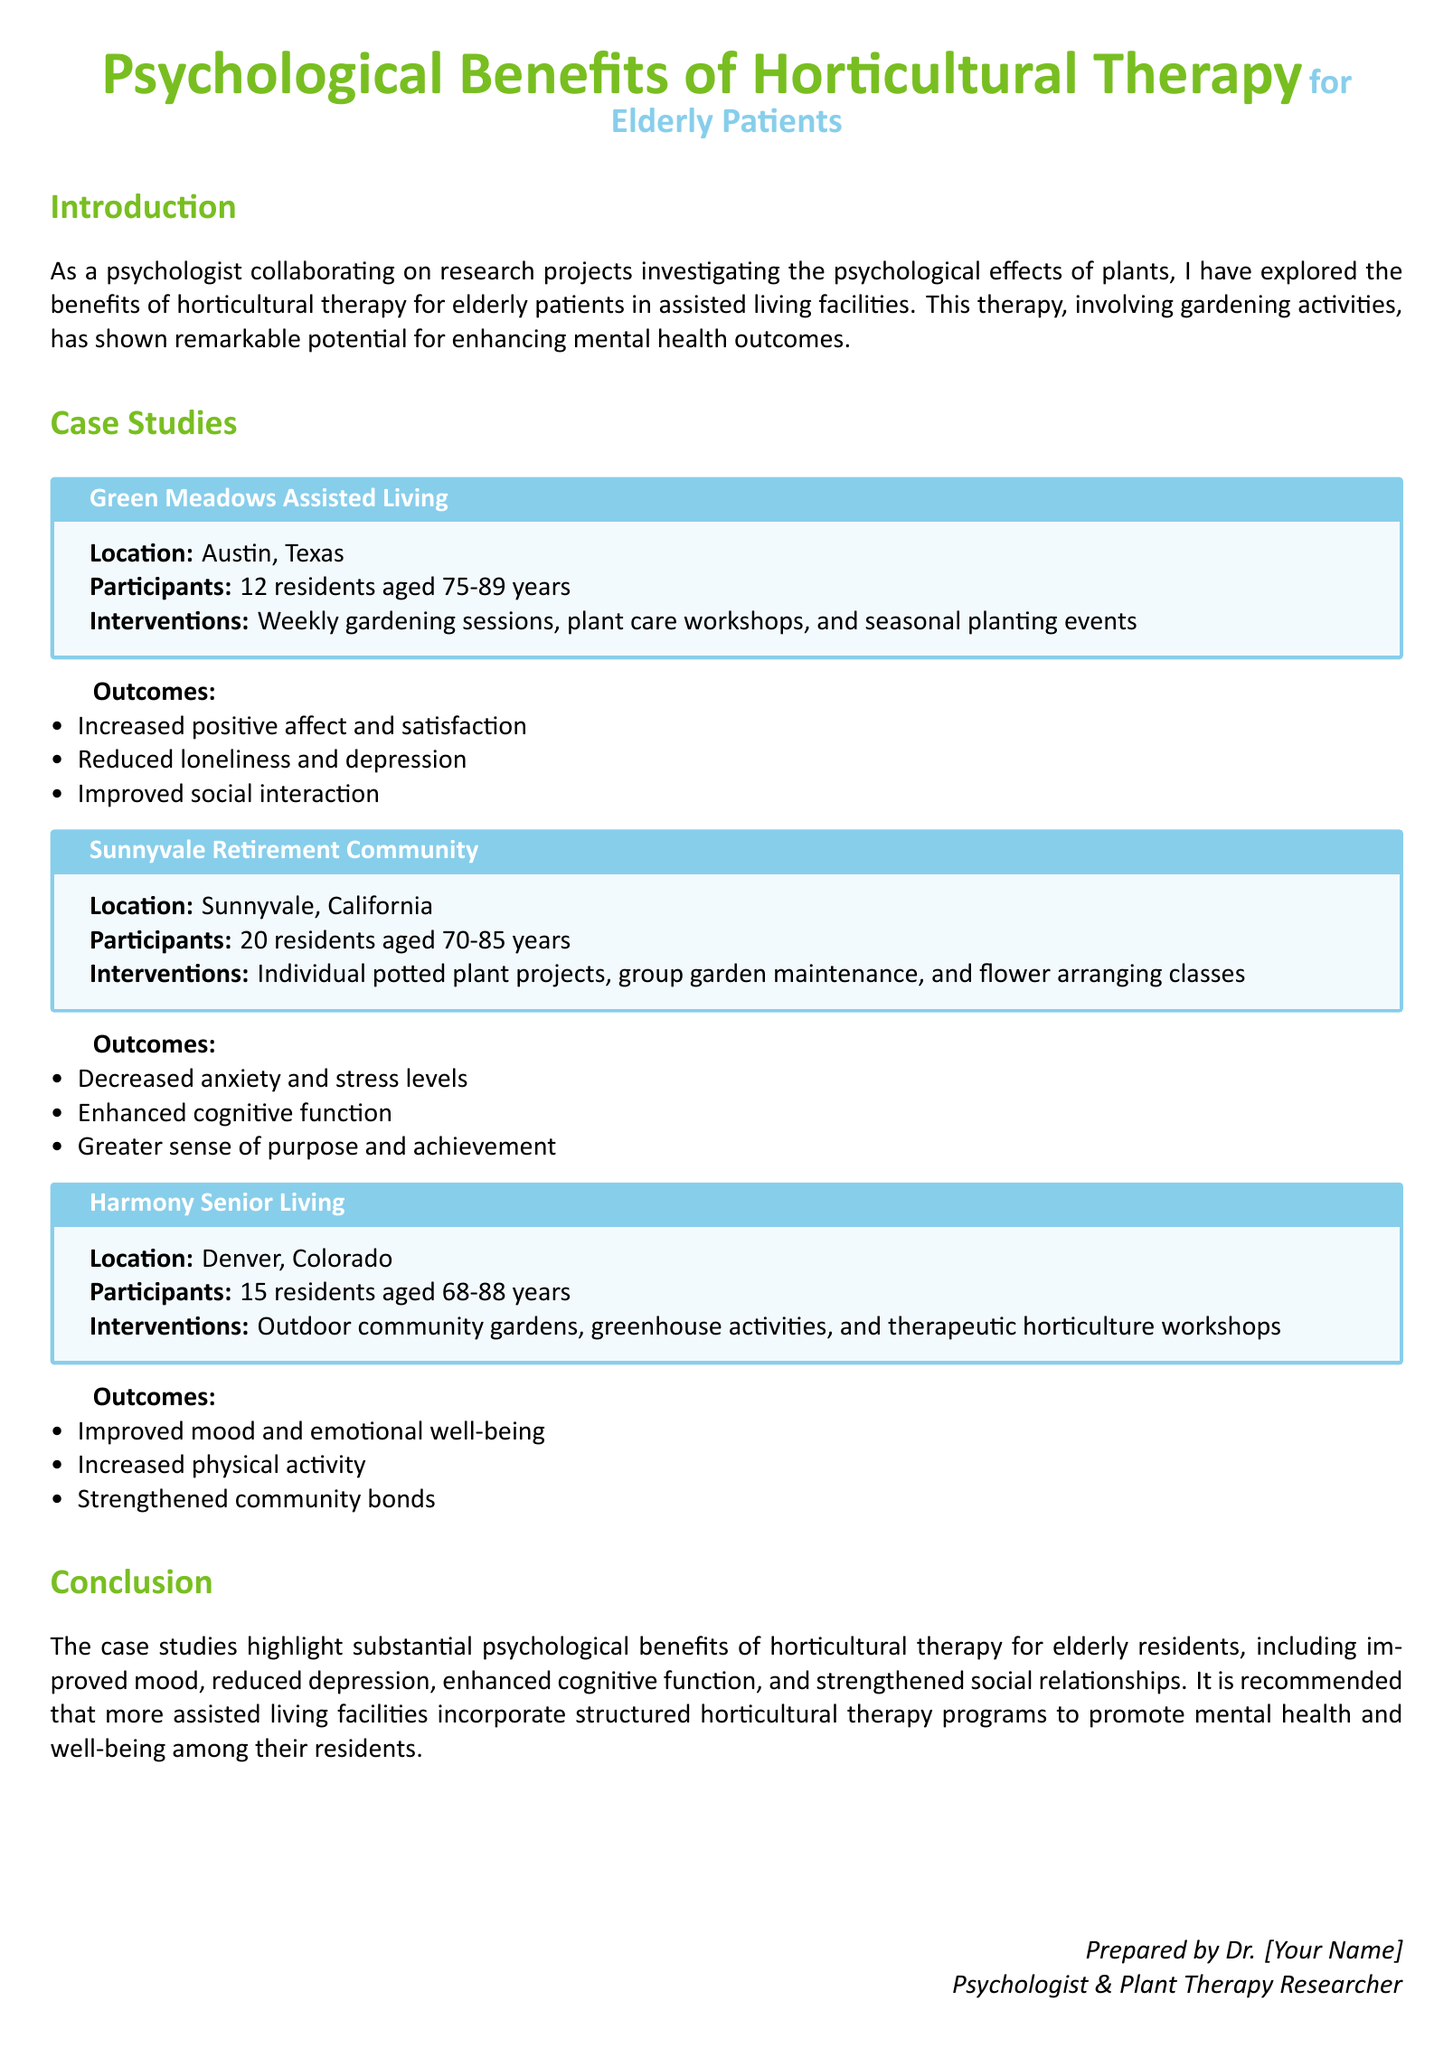What is the location of Green Meadows Assisted Living? The document specifies that Green Meadows Assisted Living is located in Austin, Texas.
Answer: Austin, Texas How many residents participated in the Sunnyvale Retirement Community case study? The case study mentions that there were 20 residents aged 70-85 years.
Answer: 20 residents What activities were involved in the Harmony Senior Living case study? The document lists outdoor community gardens, greenhouse activities, and therapeutic horticulture workshops as activities.
Answer: Outdoor community gardens, greenhouse activities, and therapeutic horticulture workshops What was one of the psychological outcomes observed at Green Meadows Assisted Living? The document states that one outcome was increased positive affect and satisfaction.
Answer: Increased positive affect and satisfaction Which age group was involved in the Green Meadows Assisted Living case study? This case study included 12 residents aged 75-89 years.
Answer: 75-89 years What is one psychological benefit reported from Sunnyvale Retirement Community? The document mentions decreased anxiety and stress levels as a psychological benefit.
Answer: Decreased anxiety and stress levels How many case studies are presented in the document? The document outlines three case studies.
Answer: Three case studies What was the purpose of horticultural therapy according to the document? The document indicates that the therapy aims to enhance mental health outcomes for elderly patients.
Answer: Enhance mental health outcomes 